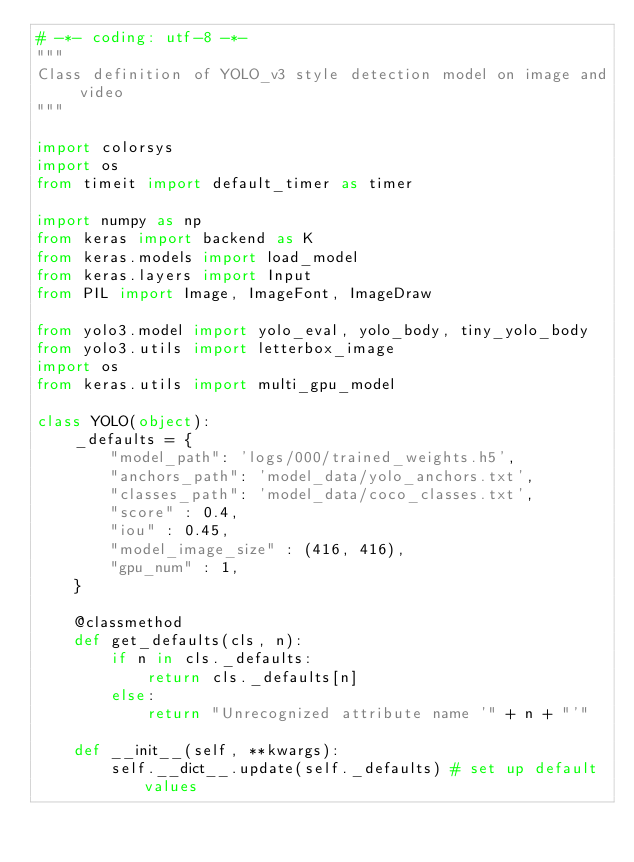Convert code to text. <code><loc_0><loc_0><loc_500><loc_500><_Python_># -*- coding: utf-8 -*-
"""
Class definition of YOLO_v3 style detection model on image and video
"""

import colorsys
import os
from timeit import default_timer as timer

import numpy as np
from keras import backend as K
from keras.models import load_model
from keras.layers import Input
from PIL import Image, ImageFont, ImageDraw

from yolo3.model import yolo_eval, yolo_body, tiny_yolo_body
from yolo3.utils import letterbox_image
import os
from keras.utils import multi_gpu_model

class YOLO(object):
    _defaults = {
        "model_path": 'logs/000/trained_weights.h5',
        "anchors_path": 'model_data/yolo_anchors.txt',
        "classes_path": 'model_data/coco_classes.txt',
        "score" : 0.4,
        "iou" : 0.45,
        "model_image_size" : (416, 416),
        "gpu_num" : 1,
    }

    @classmethod
    def get_defaults(cls, n):
        if n in cls._defaults:
            return cls._defaults[n]
        else:
            return "Unrecognized attribute name '" + n + "'"

    def __init__(self, **kwargs):
        self.__dict__.update(self._defaults) # set up default values</code> 